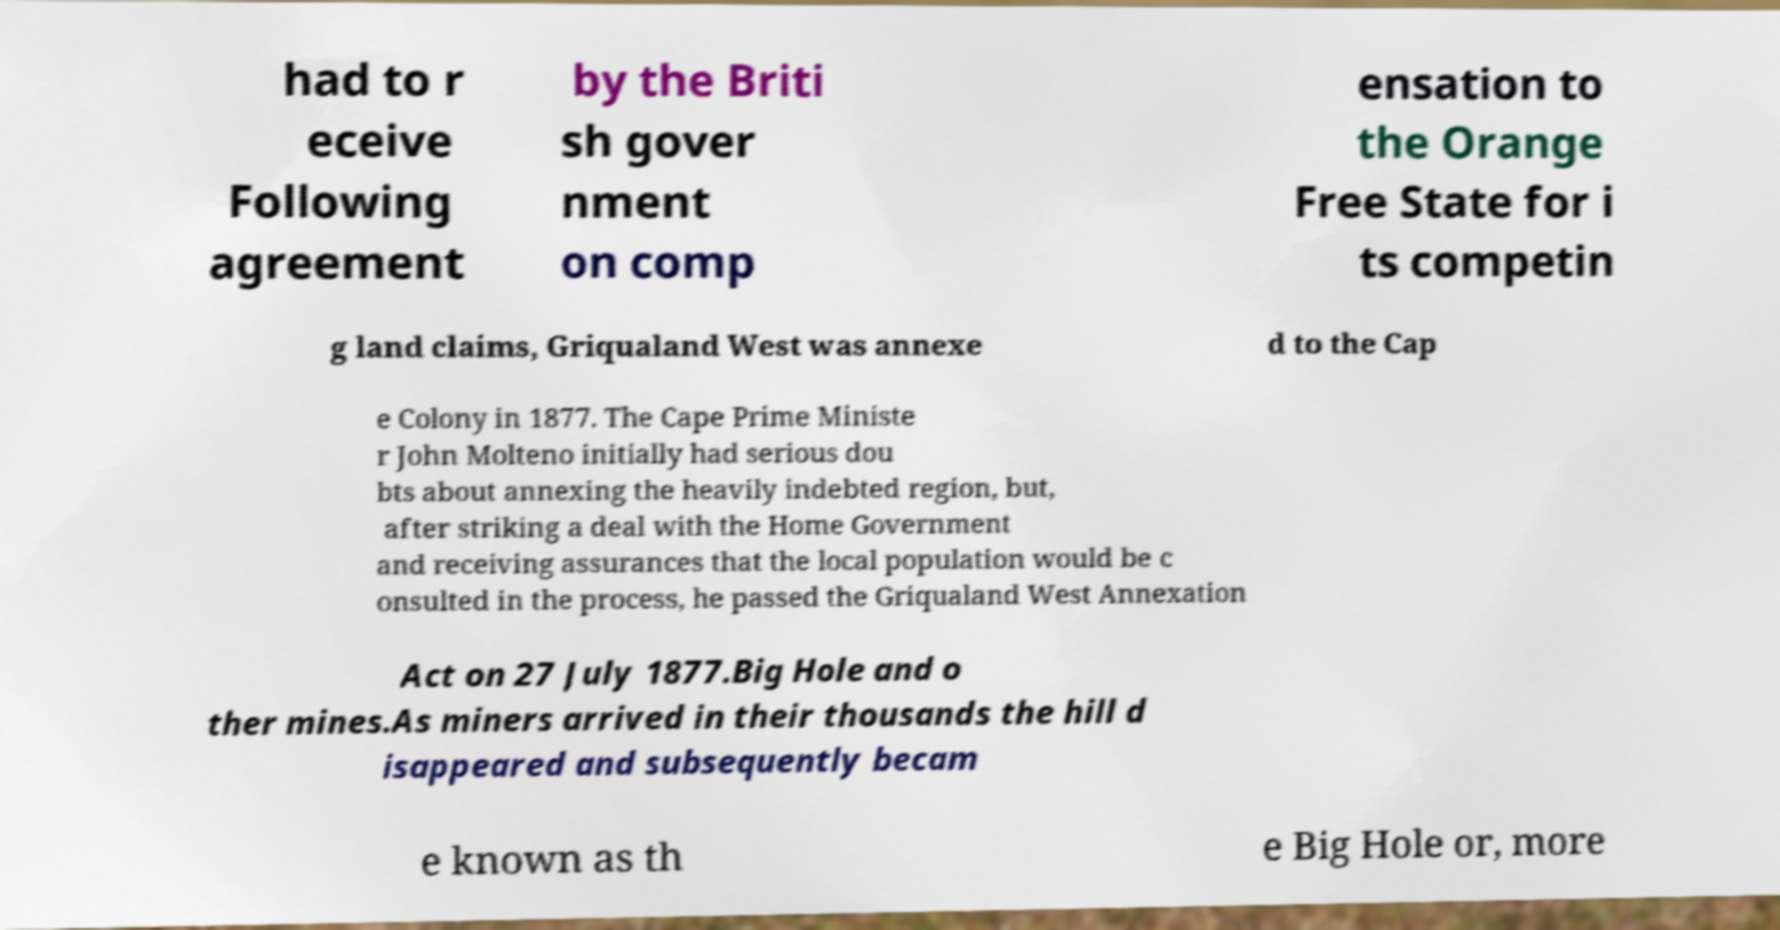For documentation purposes, I need the text within this image transcribed. Could you provide that? had to r eceive Following agreement by the Briti sh gover nment on comp ensation to the Orange Free State for i ts competin g land claims, Griqualand West was annexe d to the Cap e Colony in 1877. The Cape Prime Ministe r John Molteno initially had serious dou bts about annexing the heavily indebted region, but, after striking a deal with the Home Government and receiving assurances that the local population would be c onsulted in the process, he passed the Griqualand West Annexation Act on 27 July 1877.Big Hole and o ther mines.As miners arrived in their thousands the hill d isappeared and subsequently becam e known as th e Big Hole or, more 